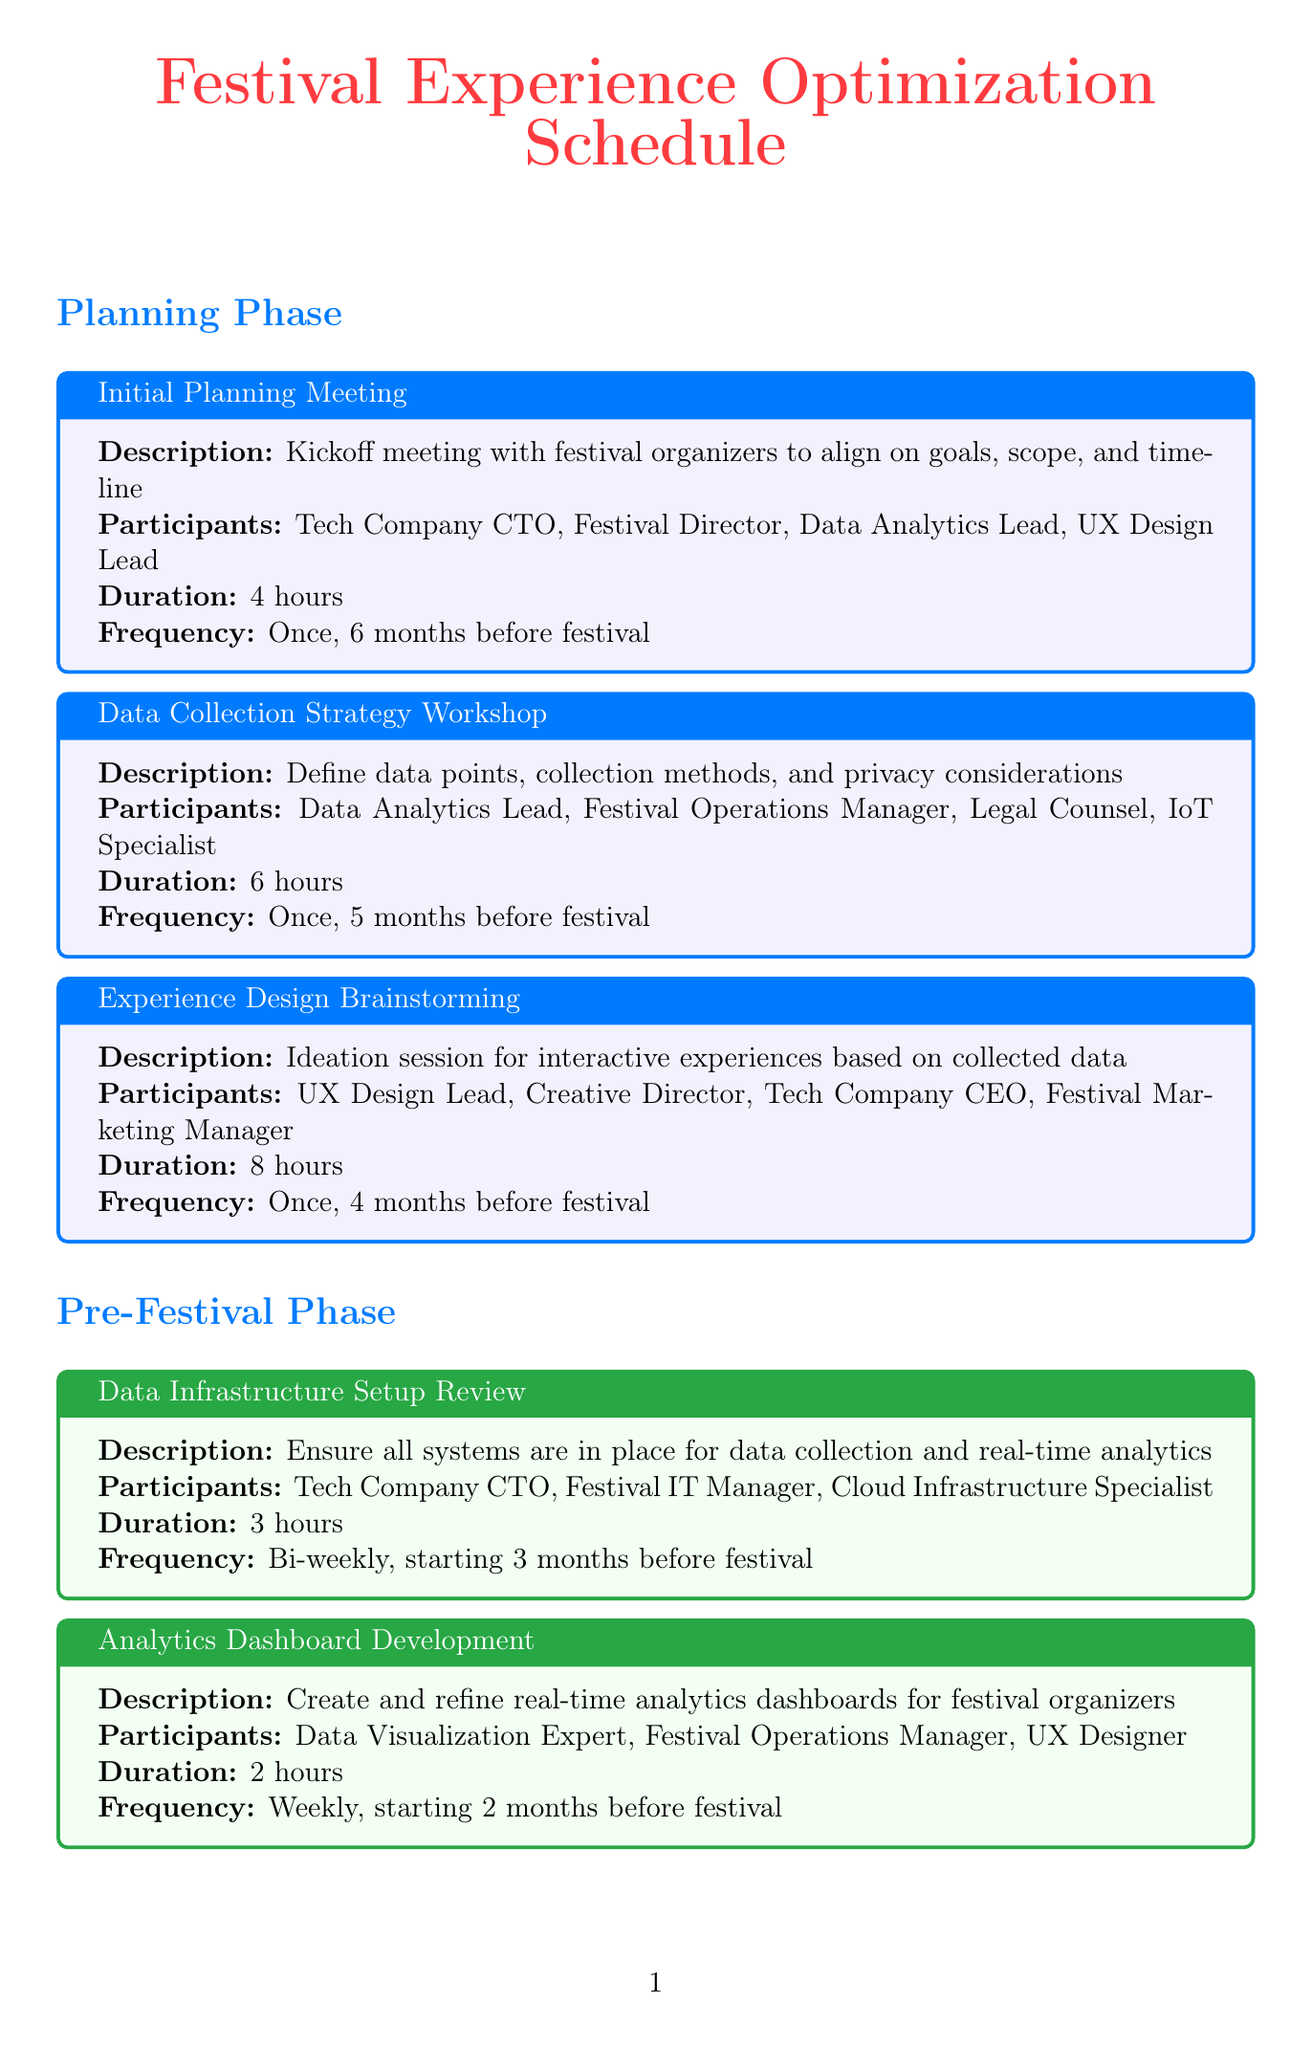what is the duration of the Initial Planning Meeting? The duration of the Initial Planning Meeting is specified in the document.
Answer: 4 hours how many participants are involved in the Data Collection Strategy Workshop? The number of participants is listed alongside each meeting in the document.
Answer: 4 participants when does the Experience Optimization Workshop take place? The frequency of the Experience Optimization Workshop is mentioned in the document.
Answer: Every 2 weeks, starting 2 months before festival who is the Festival Director that participates in the Daily Data Review Breakfast? The Daily Data Review Breakfast lists the participants involved in that specific meeting.
Answer: Festival Director how often is the Real-time Analytics Check-in held during the festival? The document provides the frequency of the Real-time Analytics Check-in meeting.
Answer: Every 4 hours during festival which meeting involves the Tech Company CTO, Festival Director, and Data Analytics Lead? The document lists participants for each meeting; this was noted for multiple meetings.
Answer: Daily Data Review Breakfast what is the purpose of the Comprehensive Data Analysis Meeting? The document describes the objectives of each meeting, specifically the Comprehensive Data Analysis Meeting.
Answer: In-depth review of all collected data and its impact on festival experiences how long is the Future Planning and Innovation Session? The document specifies the duration for each meeting, including the Future Planning and Innovation Session.
Answer: 6 hours what is the frequency of the Experience Optimization Huddle? The frequency of the Experience Optimization Huddle is detailed in the document.
Answer: Twice daily during festival, 1:00 PM and 8:00 PM 